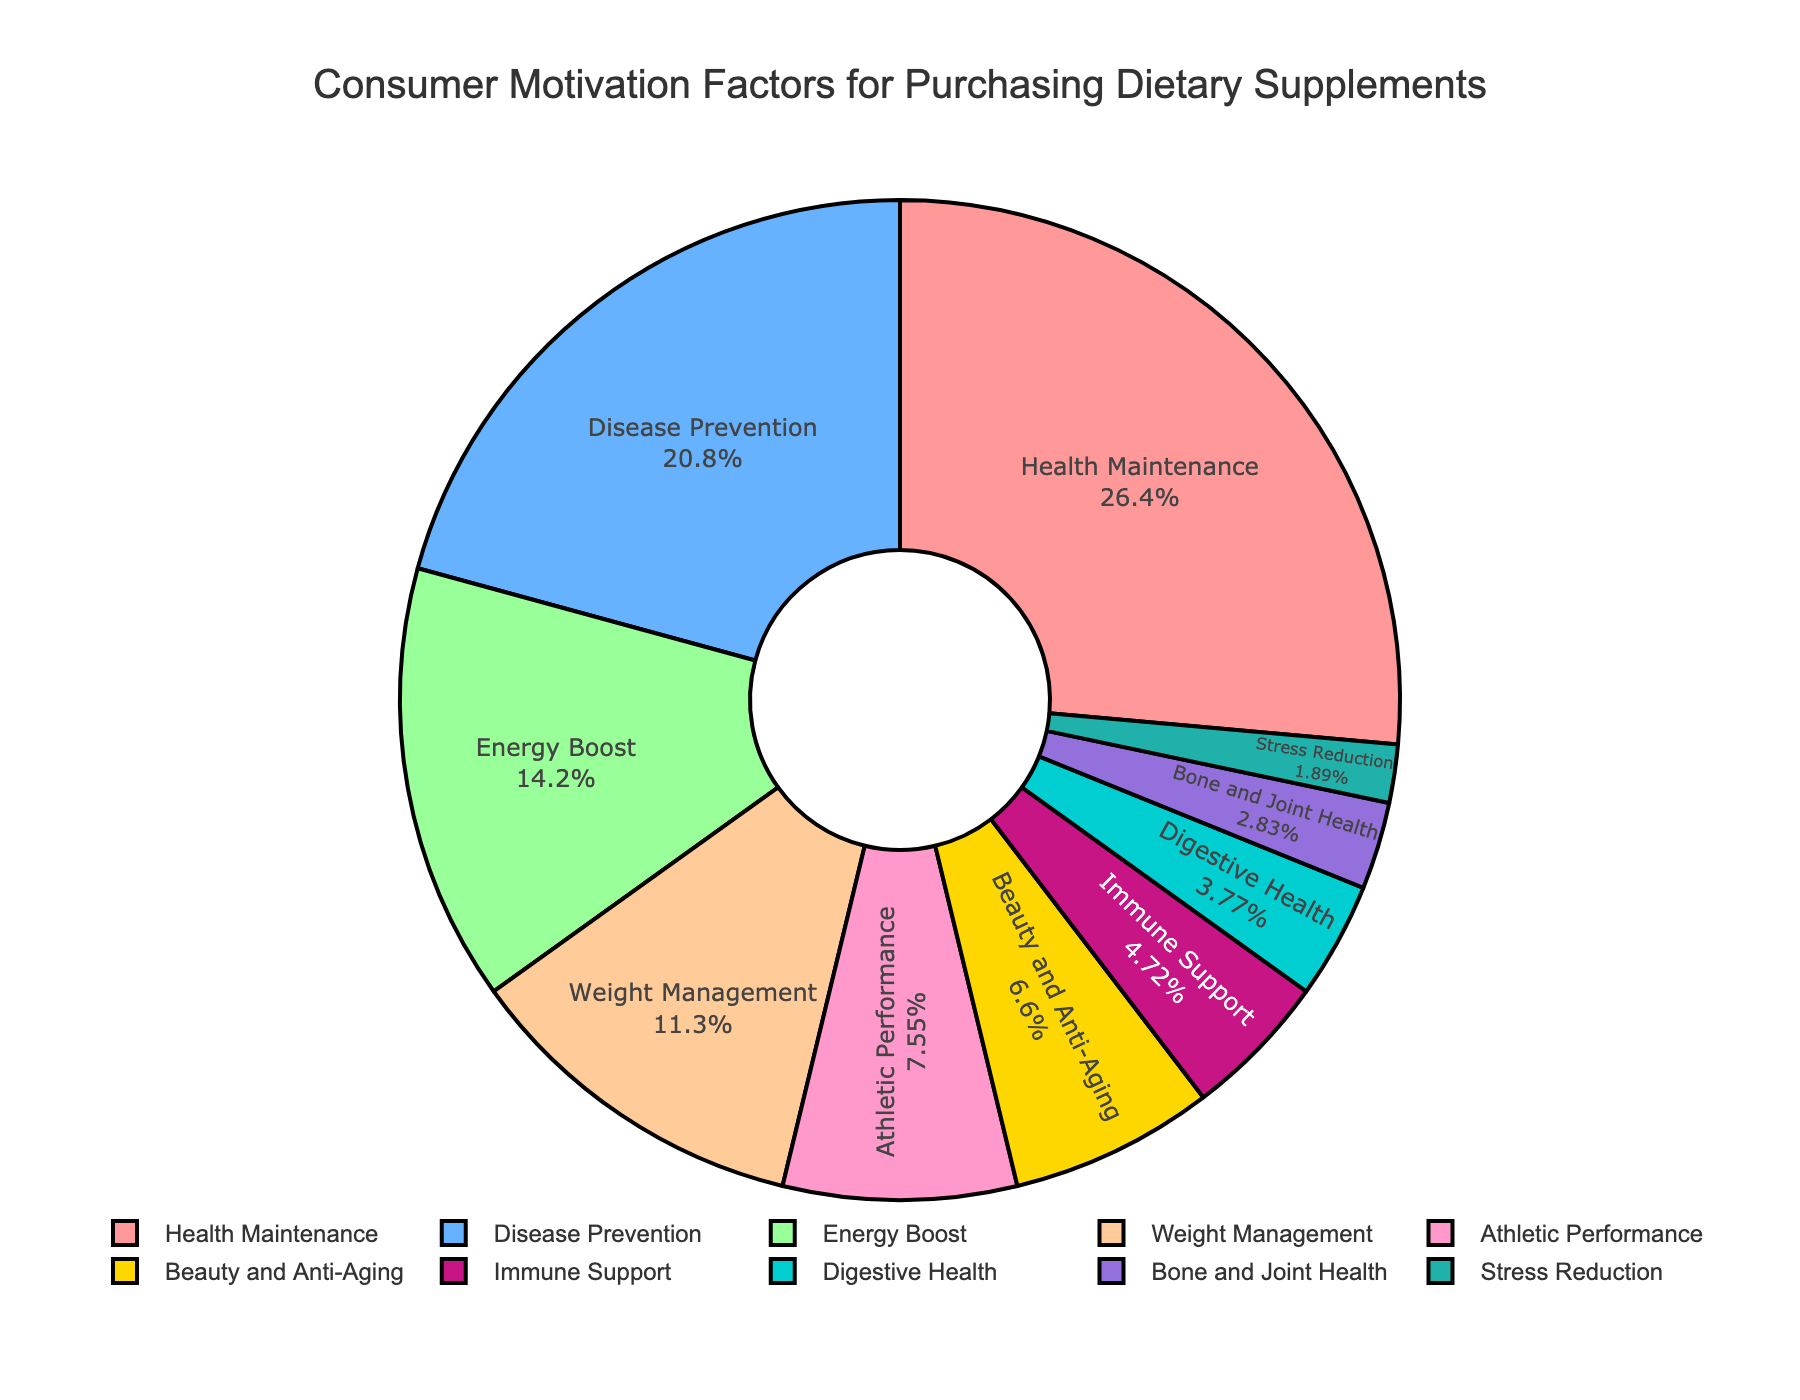What's the largest motivation factor for purchasing dietary supplements? The largest section in the pie chart is labeled "Health Maintenance" with 28%, making it the biggest motivation factor.
Answer: Health Maintenance Which motivation factor has a higher percentage, Disease Prevention or Energy Boost? According to the pie chart, Disease Prevention is 22% and Energy Boost is 15%, so Disease Prevention has a higher percentage.
Answer: Disease Prevention What is the total percentage of the top three motivation factors? The top three motivation factors are Health Maintenance (28%), Disease Prevention (22%), and Energy Boost (15%). Summing these gives 28 + 22 + 15 = 65%.
Answer: 65% Which is smaller, Immune Support or Digestive Health? The pie chart shows Immune Support at 5% and Digestive Health at 4%. Since 4% is smaller than 5%, Digestive Health is smaller.
Answer: Digestive Health What is the combined percentage of all motivation factors related to physical appearance and performance? The relevant factors are Beauty and Anti-Aging (7%) and Athletic Performance (8%). Adding these gives 7 + 8 = 15%.
Answer: 15% What's the difference in percentage between Weight Management and Digestive Health? Weight Management is 12% and Digestive Health is 4%. The difference is 12 - 4 = 8%.
Answer: 8% Which section is represented by the light blue color? Upon visual inspection, the section colored light blue corresponds to the label "Energy Boost".
Answer: Energy Boost What percentage of consumers are motivated by Beauty and Anti-Aging compared to Bone and Joint Health? Beauty and Anti-Aging is 7% while Bone and Joint Health is 3%. The comparison is 7% vs 3%, so Beauty and Anti-Aging is more.
Answer: Beauty and Anti-Aging Add up the percentages of the three smallest motivation factors. The smallest factors are Bone and Joint Health (3%), Stress Reduction (2%), and Digestive Health (4%). Their sum is 3 + 2 + 4 = 9%.
Answer: 9% What's the total percentage for Weight Management and Athletic Performance combined? Weight Management is 12% and Athletic Performance is 8%. Adding them gives 12 + 8 = 20%.
Answer: 20% 